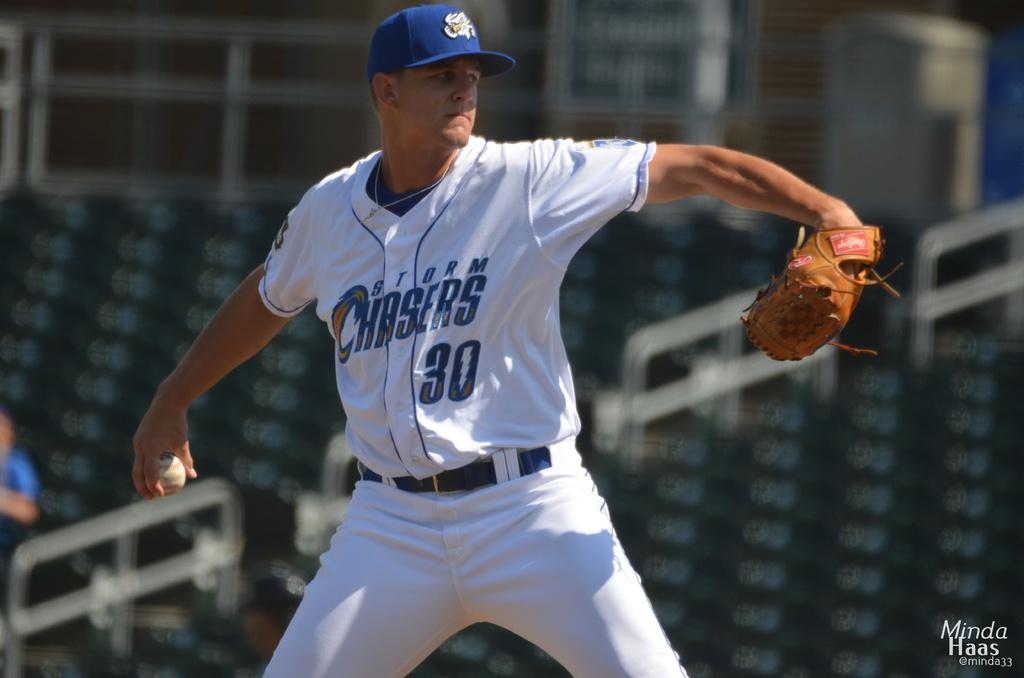<image>
Share a concise interpretation of the image provided. A player from the Storm Chasers is pitching 